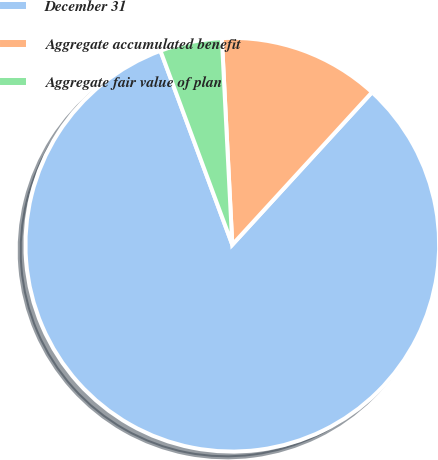Convert chart. <chart><loc_0><loc_0><loc_500><loc_500><pie_chart><fcel>December 31<fcel>Aggregate accumulated benefit<fcel>Aggregate fair value of plan<nl><fcel>82.54%<fcel>12.61%<fcel>4.84%<nl></chart> 